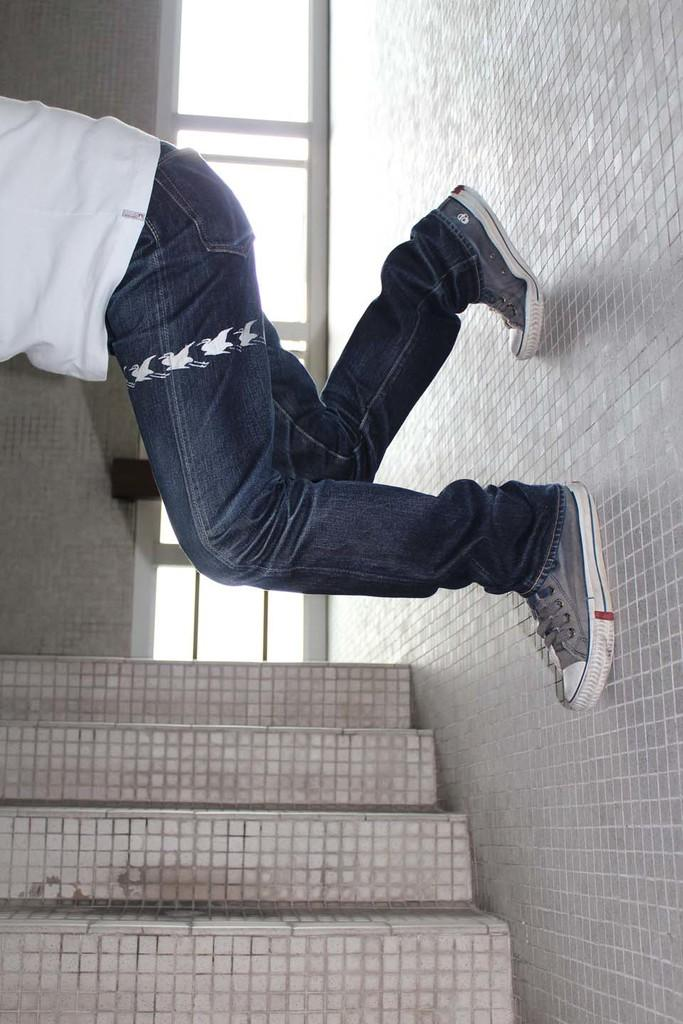What is the main subject of the image? There is a person in the image. What type of clothing is the person wearing? The person is wearing a t-shirt, jeans, and shoes. What can be seen in the background of the image? There is a wall and tiles visible in the image. What type of oven can be seen in the image? There is no oven present in the image. Is the person walking in the yard in the image? There is no yard visible in the image, and the person's activity is not mentioned. 